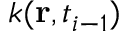<formula> <loc_0><loc_0><loc_500><loc_500>k ( r , t _ { i - 1 } )</formula> 